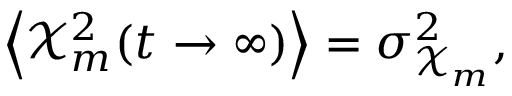<formula> <loc_0><loc_0><loc_500><loc_500>\left < \mathcal { X } _ { m } ^ { 2 } ( t \to \infty ) \right > = \sigma _ { \mathcal { X } _ { m } } ^ { 2 } ,</formula> 